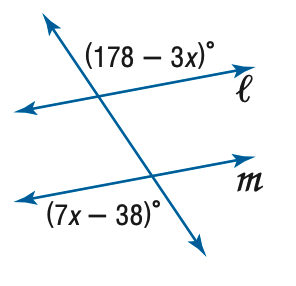Question: Find x so that m \parallel n.
Choices:
A. 14
B. 21.6
C. 28
D. 35
Answer with the letter. Answer: B 